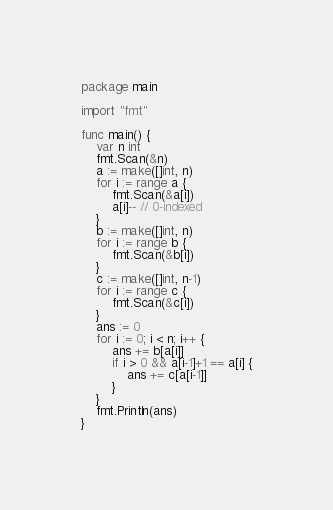<code> <loc_0><loc_0><loc_500><loc_500><_Go_>package main

import "fmt"

func main() {
	var n int
	fmt.Scan(&n)
	a := make([]int, n)
	for i := range a {
		fmt.Scan(&a[i])
		a[i]-- // 0-indexed
	}
	b := make([]int, n)
	for i := range b {
		fmt.Scan(&b[i])
	}
	c := make([]int, n-1)
	for i := range c {
		fmt.Scan(&c[i])
	}
	ans := 0
	for i := 0; i < n; i++ {
		ans += b[a[i]]
		if i > 0 && a[i-1]+1 == a[i] {
			ans += c[a[i-1]]
		}
	}
	fmt.Println(ans)
}
</code> 